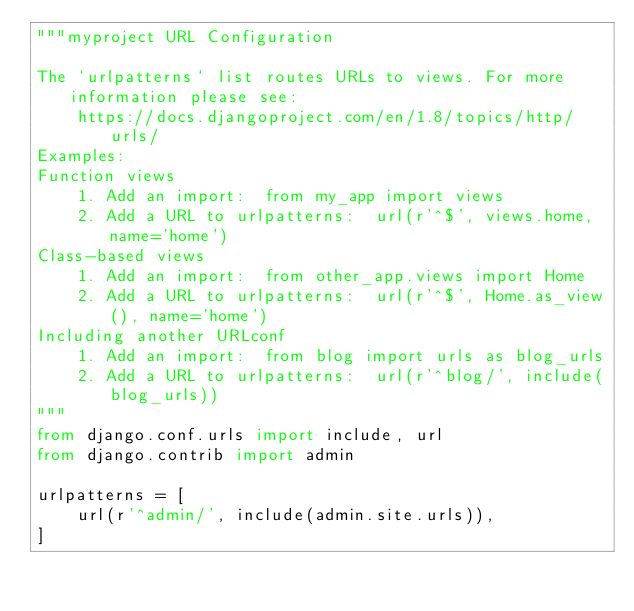<code> <loc_0><loc_0><loc_500><loc_500><_Python_>"""myproject URL Configuration

The `urlpatterns` list routes URLs to views. For more information please see:
    https://docs.djangoproject.com/en/1.8/topics/http/urls/
Examples:
Function views
    1. Add an import:  from my_app import views
    2. Add a URL to urlpatterns:  url(r'^$', views.home, name='home')
Class-based views
    1. Add an import:  from other_app.views import Home
    2. Add a URL to urlpatterns:  url(r'^$', Home.as_view(), name='home')
Including another URLconf
    1. Add an import:  from blog import urls as blog_urls
    2. Add a URL to urlpatterns:  url(r'^blog/', include(blog_urls))
"""
from django.conf.urls import include, url
from django.contrib import admin

urlpatterns = [
    url(r'^admin/', include(admin.site.urls)),
]
</code> 